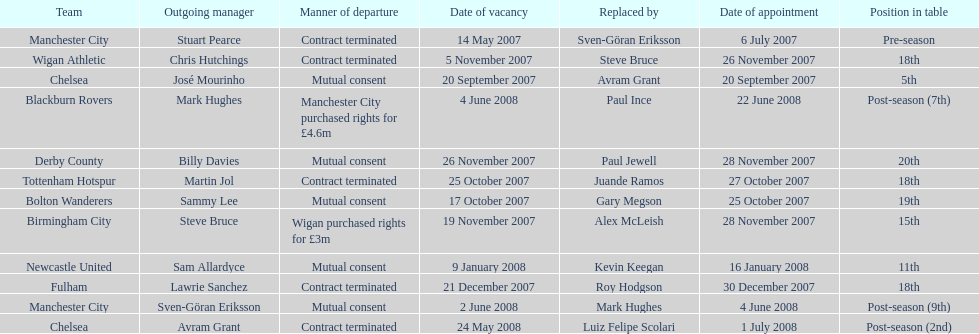In 2007, when stuart pearce left manchester city, who succeeded him as the team's manager? Sven-Göran Eriksson. 